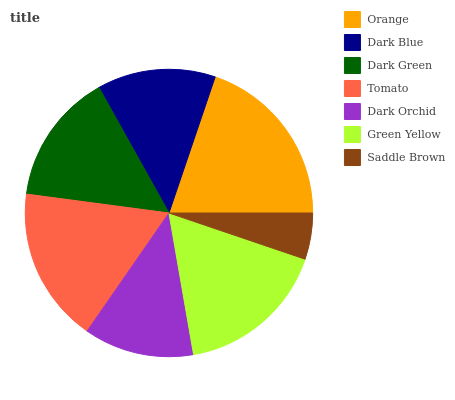Is Saddle Brown the minimum?
Answer yes or no. Yes. Is Orange the maximum?
Answer yes or no. Yes. Is Dark Blue the minimum?
Answer yes or no. No. Is Dark Blue the maximum?
Answer yes or no. No. Is Orange greater than Dark Blue?
Answer yes or no. Yes. Is Dark Blue less than Orange?
Answer yes or no. Yes. Is Dark Blue greater than Orange?
Answer yes or no. No. Is Orange less than Dark Blue?
Answer yes or no. No. Is Dark Green the high median?
Answer yes or no. Yes. Is Dark Green the low median?
Answer yes or no. Yes. Is Tomato the high median?
Answer yes or no. No. Is Dark Blue the low median?
Answer yes or no. No. 